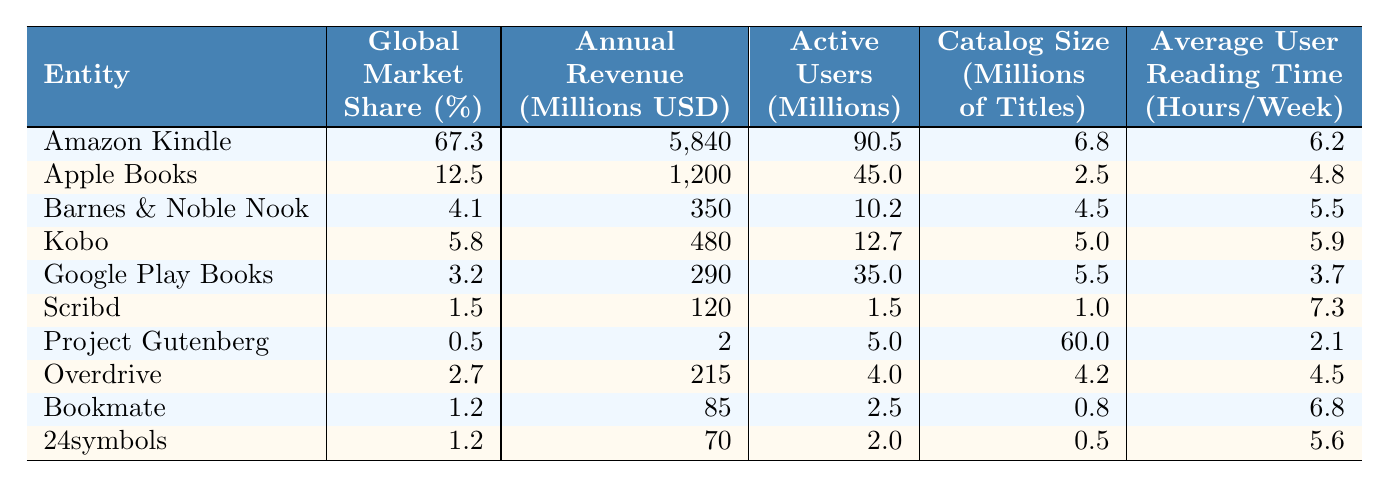What is the global market share percentage of Amazon Kindle? The table shows that Amazon Kindle has a global market share of 67.3%.
Answer: 67.3% Which platform has the highest annual revenue? From the table, Amazon Kindle has the highest annual revenue at 5840 million USD.
Answer: Amazon Kindle What is the average catalog size of the platforms listed? To find the average, sum the catalog sizes (6.8 + 2.5 + 4.5 + 5.0 + 5.5 + 1.0 + 60.0 + 4.2 + 0.8 + 0.5) = 91.8 million titles and divide by 10, giving an average of 9.18 million titles.
Answer: 9.18 million titles Is the active user count for Apple Books greater than that of Google Play Books? Apple Books has 45.0 million active users, while Google Play Books has 35.0 million, making the statement true.
Answer: Yes Which e-book reader has the least active users? Project Gutenberg has the least active users with only 5.0 million.
Answer: Project Gutenberg What is the combined annual revenue of the top three platforms? Adding the annual revenues of Amazon Kindle (5840), Apple Books (1200), and Barnes & Noble Nook (350) gives 5840 + 1200 + 350 = 7390 million USD.
Answer: 7390 million USD Which platform has the highest average user reading time? Scribd has the highest average user reading time at 7.3 hours per week.
Answer: Scribd Is there a platform with zero catalog size? Since all platforms have listed catalog sizes, the answer is no.
Answer: No What is the difference in global market share between Apple Books and Kobo? Apple Books has a global market share of 12.5%, while Kobo has 5.8%. The difference is 12.5 - 5.8 = 6.7%.
Answer: 6.7% What is the average active user count across all platforms? The total active users are 90.5 + 45.0 + 10.2 + 12.7 + 35.0 + 1.5 + 5.0 + 4.0 + 2.5 + 2.0 = 203.4 million. Dividing by 10, the average is 20.34 million active users.
Answer: 20.34 million active users 